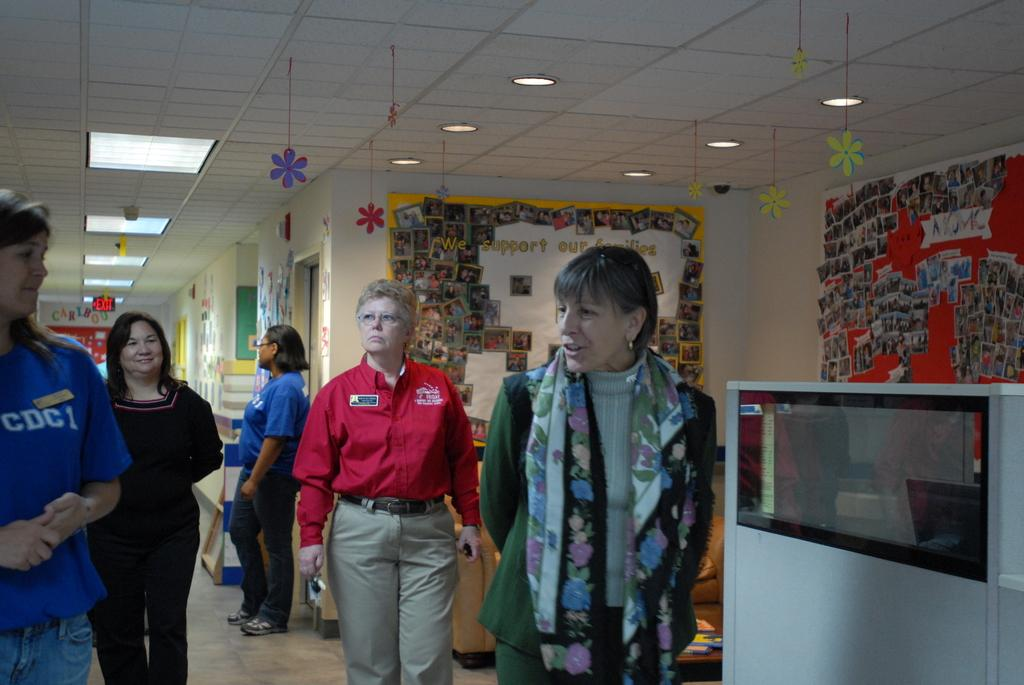<image>
Present a compact description of the photo's key features. A yellow poster has a collection of photographs and the message We support our families. 